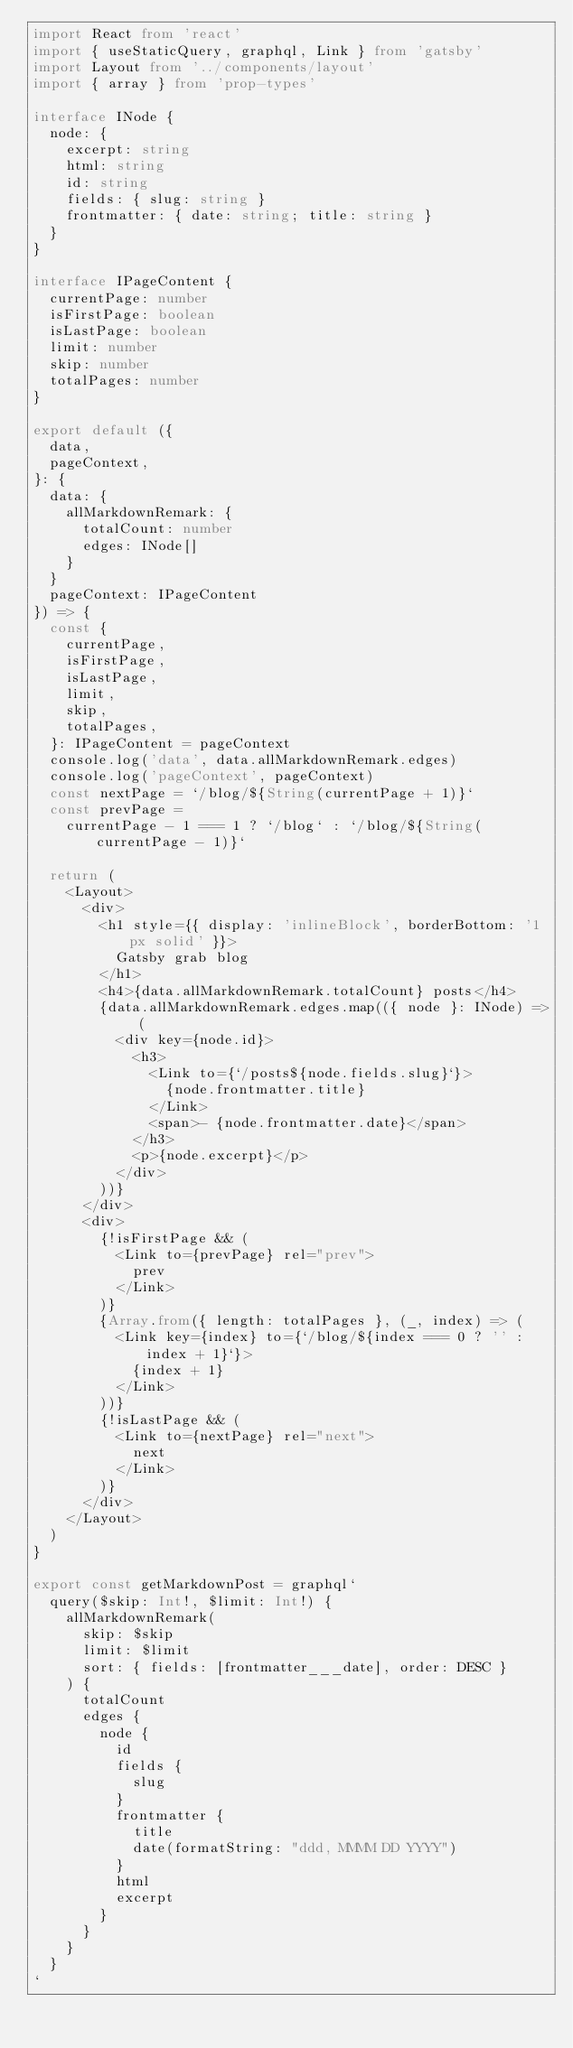<code> <loc_0><loc_0><loc_500><loc_500><_TypeScript_>import React from 'react'
import { useStaticQuery, graphql, Link } from 'gatsby'
import Layout from '../components/layout'
import { array } from 'prop-types'

interface INode {
  node: {
    excerpt: string
    html: string
    id: string
    fields: { slug: string }
    frontmatter: { date: string; title: string }
  }
}

interface IPageContent {
  currentPage: number
  isFirstPage: boolean
  isLastPage: boolean
  limit: number
  skip: number
  totalPages: number
}

export default ({
  data,
  pageContext,
}: {
  data: {
    allMarkdownRemark: {
      totalCount: number
      edges: INode[]
    }
  }
  pageContext: IPageContent
}) => {
  const {
    currentPage,
    isFirstPage,
    isLastPage,
    limit,
    skip,
    totalPages,
  }: IPageContent = pageContext
  console.log('data', data.allMarkdownRemark.edges)
  console.log('pageContext', pageContext)
  const nextPage = `/blog/${String(currentPage + 1)}`
  const prevPage =
    currentPage - 1 === 1 ? `/blog` : `/blog/${String(currentPage - 1)}`

  return (
    <Layout>
      <div>
        <h1 style={{ display: 'inlineBlock', borderBottom: '1px solid' }}>
          Gatsby grab blog
        </h1>
        <h4>{data.allMarkdownRemark.totalCount} posts</h4>
        {data.allMarkdownRemark.edges.map(({ node }: INode) => (
          <div key={node.id}>
            <h3>
              <Link to={`/posts${node.fields.slug}`}>
                {node.frontmatter.title}
              </Link>
              <span>- {node.frontmatter.date}</span>
            </h3>
            <p>{node.excerpt}</p>
          </div>
        ))}
      </div>
      <div>
        {!isFirstPage && (
          <Link to={prevPage} rel="prev">
            prev
          </Link>
        )}
        {Array.from({ length: totalPages }, (_, index) => (
          <Link key={index} to={`/blog/${index === 0 ? '' : index + 1}`}>
            {index + 1}
          </Link>
        ))}
        {!isLastPage && (
          <Link to={nextPage} rel="next">
            next
          </Link>
        )}
      </div>
    </Layout>
  )
}

export const getMarkdownPost = graphql`
  query($skip: Int!, $limit: Int!) {
    allMarkdownRemark(
      skip: $skip
      limit: $limit
      sort: { fields: [frontmatter___date], order: DESC }
    ) {
      totalCount
      edges {
        node {
          id
          fields {
            slug
          }
          frontmatter {
            title
            date(formatString: "ddd, MMMM DD YYYY")
          }
          html
          excerpt
        }
      }
    }
  }
`
</code> 